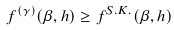<formula> <loc_0><loc_0><loc_500><loc_500>f ^ { ( \gamma ) } ( \beta , h ) \geq f ^ { S . K . } ( \beta , h )</formula> 